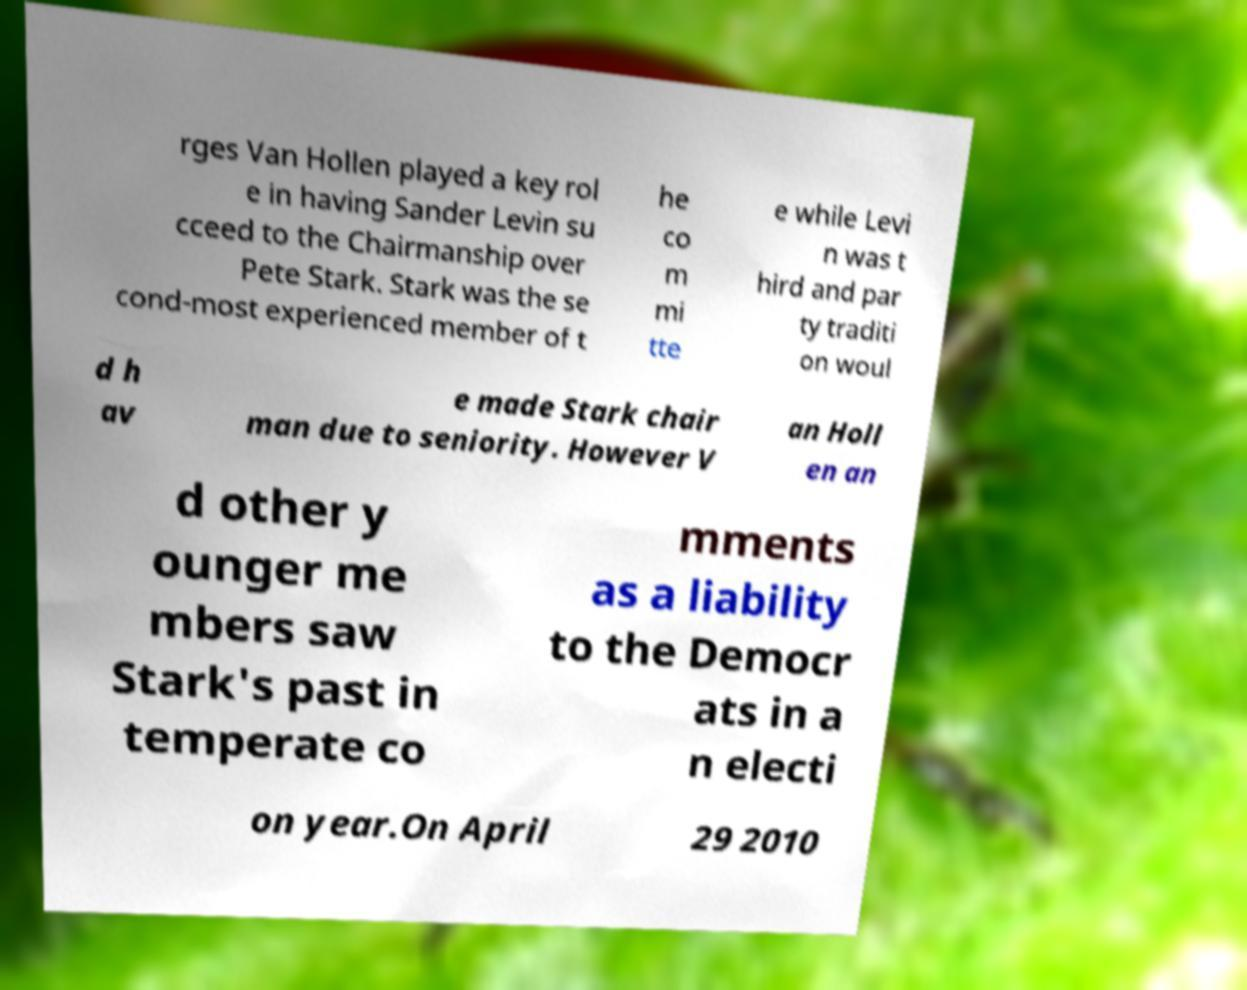For documentation purposes, I need the text within this image transcribed. Could you provide that? rges Van Hollen played a key rol e in having Sander Levin su cceed to the Chairmanship over Pete Stark. Stark was the se cond-most experienced member of t he co m mi tte e while Levi n was t hird and par ty traditi on woul d h av e made Stark chair man due to seniority. However V an Holl en an d other y ounger me mbers saw Stark's past in temperate co mments as a liability to the Democr ats in a n electi on year.On April 29 2010 